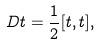Convert formula to latex. <formula><loc_0><loc_0><loc_500><loc_500>D t = \frac { 1 } { 2 } [ t , t ] ,</formula> 